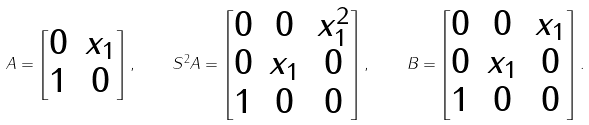<formula> <loc_0><loc_0><loc_500><loc_500>A = \begin{bmatrix} 0 & x _ { 1 } \\ 1 & 0 \end{bmatrix} , \quad S ^ { 2 } A = \begin{bmatrix} 0 & 0 & x _ { 1 } ^ { 2 } \\ 0 & x _ { 1 } & 0 \\ 1 & 0 & 0 \end{bmatrix} , \quad B = \begin{bmatrix} 0 & 0 & x _ { 1 } \\ 0 & x _ { 1 } & 0 \\ 1 & 0 & 0 \end{bmatrix} .</formula> 